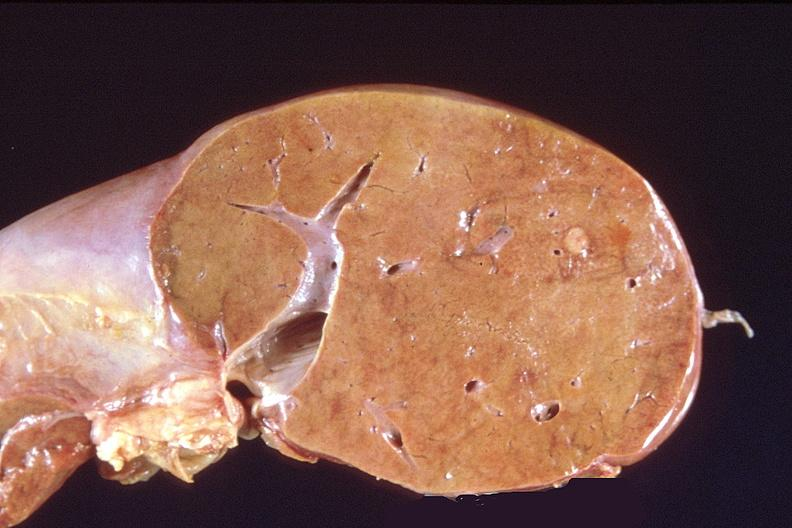does bone, calvarium show liver, metastatic breast cancer?
Answer the question using a single word or phrase. No 